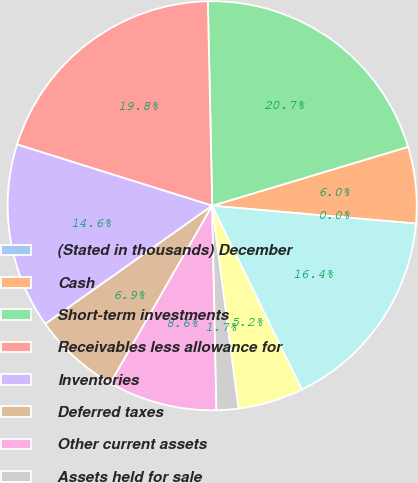Convert chart. <chart><loc_0><loc_0><loc_500><loc_500><pie_chart><fcel>(Stated in thousands) December<fcel>Cash<fcel>Short-term investments<fcel>Receivables less allowance for<fcel>Inventories<fcel>Deferred taxes<fcel>Other current assets<fcel>Assets held for sale<fcel>Fixed Income Investments held<fcel>Investments in Affiliated<nl><fcel>0.0%<fcel>6.04%<fcel>20.69%<fcel>19.82%<fcel>14.65%<fcel>6.9%<fcel>8.62%<fcel>1.73%<fcel>5.17%<fcel>16.38%<nl></chart> 